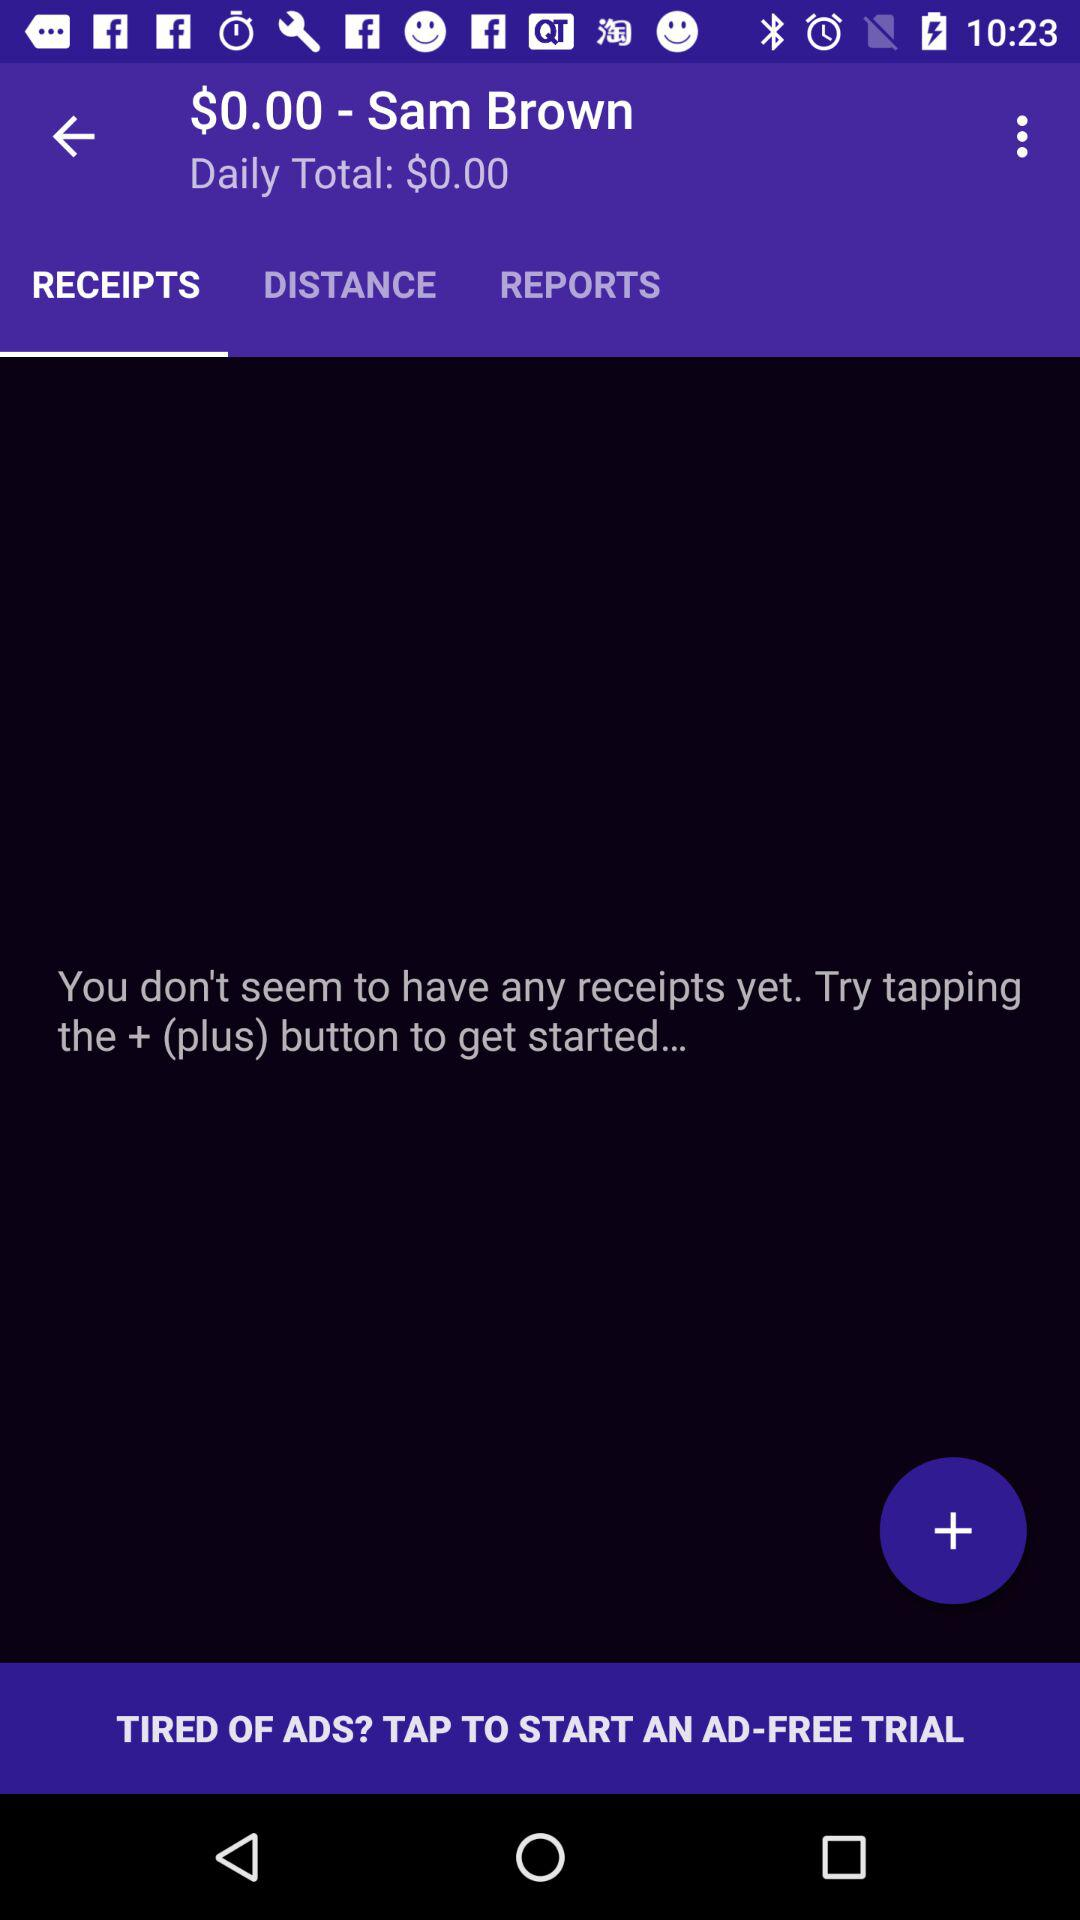What is the user name? The user name is "Sam Brown". 